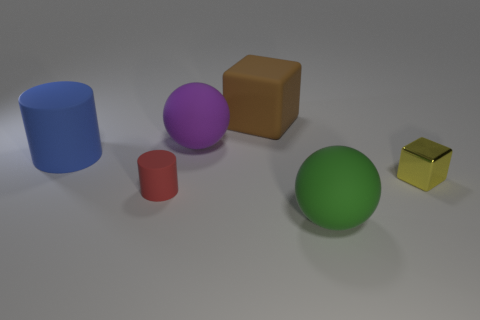Is the shape of the rubber thing on the left side of the small cylinder the same as the brown rubber thing? No, they are not the same shape. The rubber object on the left side of the small cylinder appears to be a cup or a cap that is cylindrical in shape with a circular opening, whereas the brown object is a cube with six square faces. 